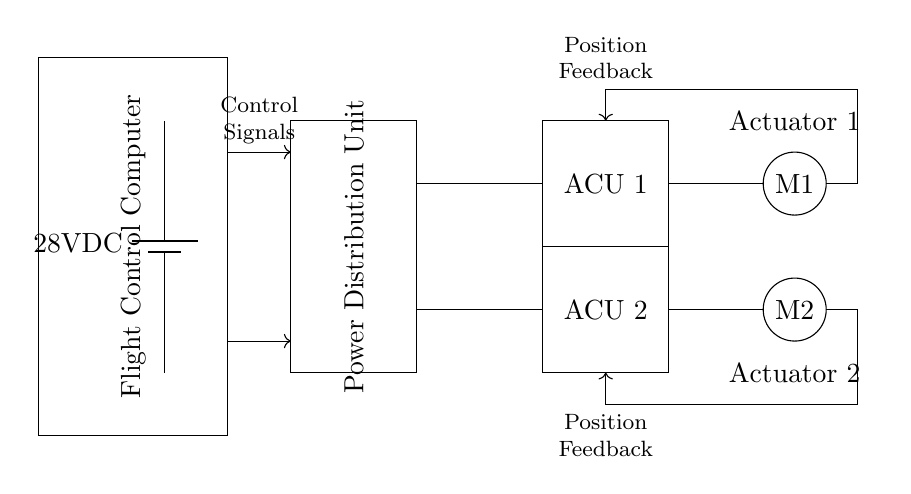What is the voltage of the power source? The power source is labeled as "28V DC" in the circuit diagram, indicating a direct current voltage of 28 volts.
Answer: 28 volts What do the rectangles labeled ACU 1 and ACU 2 represent? The rectangles labeled ACU 1 and ACU 2 represent the Actuator Control Units, which are responsible for controlling the respective actuators in the circuit.
Answer: Actuator Control Units How many actuators are shown in this circuit diagram? The diagram includes two actuators, labeled M1 and M2, indicated by the circles in the diagram.
Answer: Two What type of feedback mechanism is used for the actuators? The circuit includes position feedback lines connecting the actuators to the control units, which help in providing information about the actuators' positions.
Answer: Position feedback What is the role of the Flight Control Computer in this circuit? The Flight Control Computer processes the control signals and coordinates the operation of the Actuator Control Units for effective flight control.
Answer: Control processing In what configuration are the actuators connected to the power lines? The actuators are connected in parallel to the power lines, which allow them to receive power simultaneously and operate independently.
Answer: Parallel configuration 